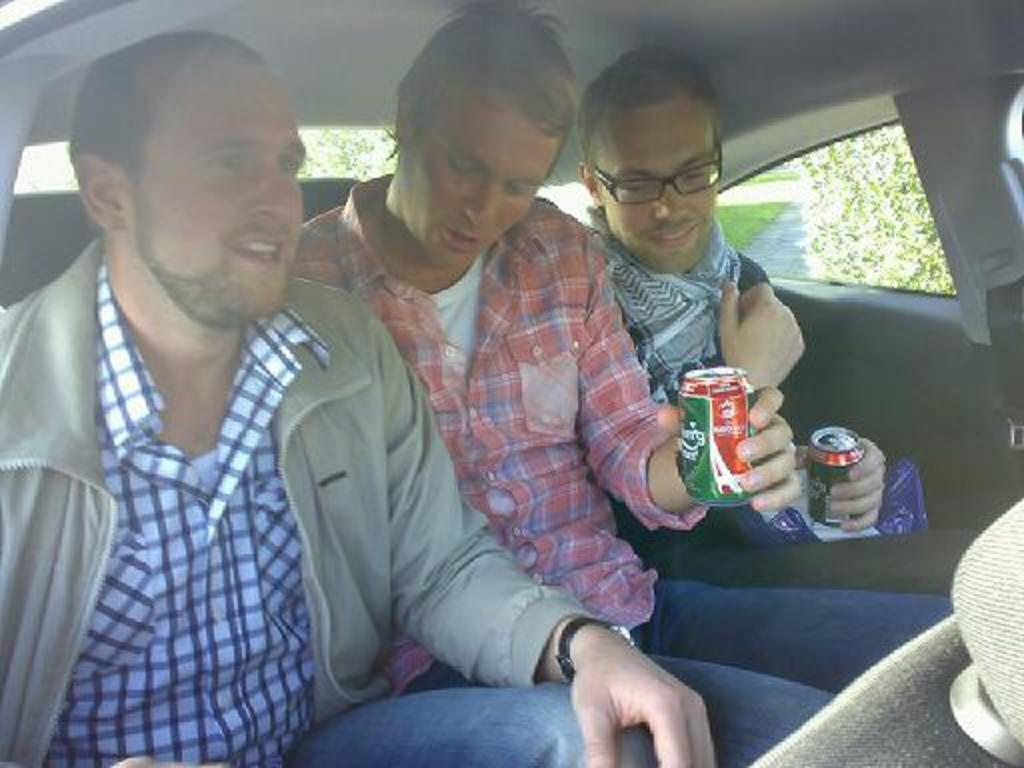Where was the image taken? The image was taken inside a car. How many people are in the car? There are three persons in the car. What is one person doing in the image? One person is talking. What are two persons holding in the image? Two persons are holding a tin. What type of coal can be seen in the image? There is no coal present in the image. What color is the pen that one person is holding in the image? There is no pen present in the image. 